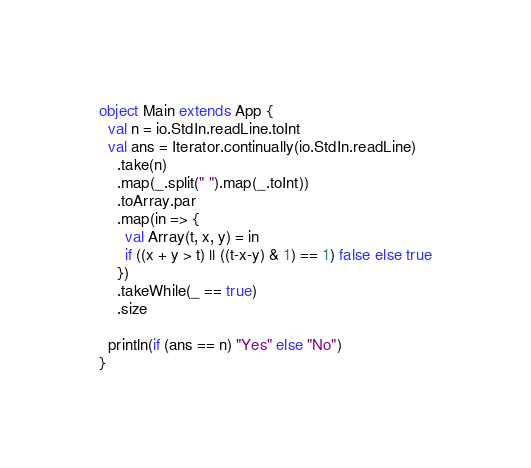Convert code to text. <code><loc_0><loc_0><loc_500><loc_500><_Scala_>object Main extends App {
  val n = io.StdIn.readLine.toInt
  val ans = Iterator.continually(io.StdIn.readLine)
    .take(n)
    .map(_.split(" ").map(_.toInt))
    .toArray.par
    .map(in => {
      val Array(t, x, y) = in
      if ((x + y > t) || ((t-x-y) & 1) == 1) false else true
    })
    .takeWhile(_ == true)
    .size

  println(if (ans == n) "Yes" else "No")
}</code> 